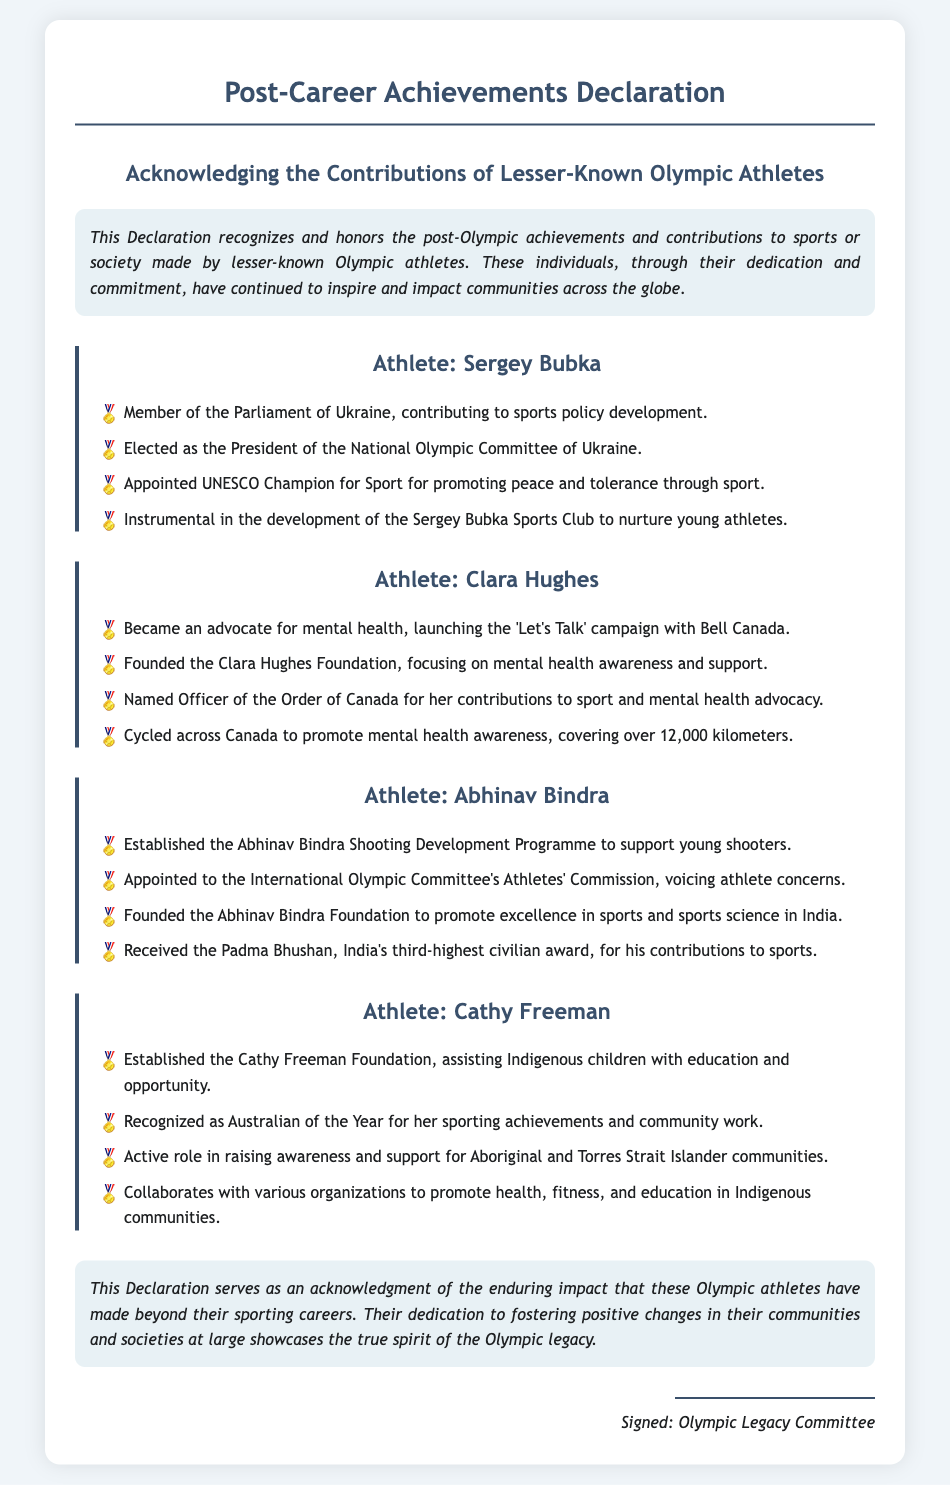What is the title of the document? The title is found at the top of the document.
Answer: Post-Career Achievements Declaration Who is recognized as an advocate for mental health? This recognition is given to Clara Hughes for her efforts outlined in the document.
Answer: Clara Hughes What foundation did Abhinav Bindra establish? The foundation is named in the section discussing his achievements.
Answer: Abhinav Bindra Foundation How many kilometers did Clara Hughes cycle across Canada? The distance is mentioned in her achievements in the document.
Answer: 12,000 kilometers What honor was received by Abhinav Bindra? This is noted under his post-career achievements section.
Answer: Padma Bhushan Which athlete founded a foundation assisting Indigenous children? The document specifies this accomplishment under one athlete.
Answer: Cathy Freeman Who signed the declaration? The signatory is mentioned at the end of the document.
Answer: Olympic Legacy Committee What role did Sergey Bubka hold in the National Olympic Committee of Ukraine? His position is listed as part of his contributions.
Answer: President How many notable post-career contributions are mentioned for Cathy Freeman? This refers to the achievements outlined in her section of the document.
Answer: Four 